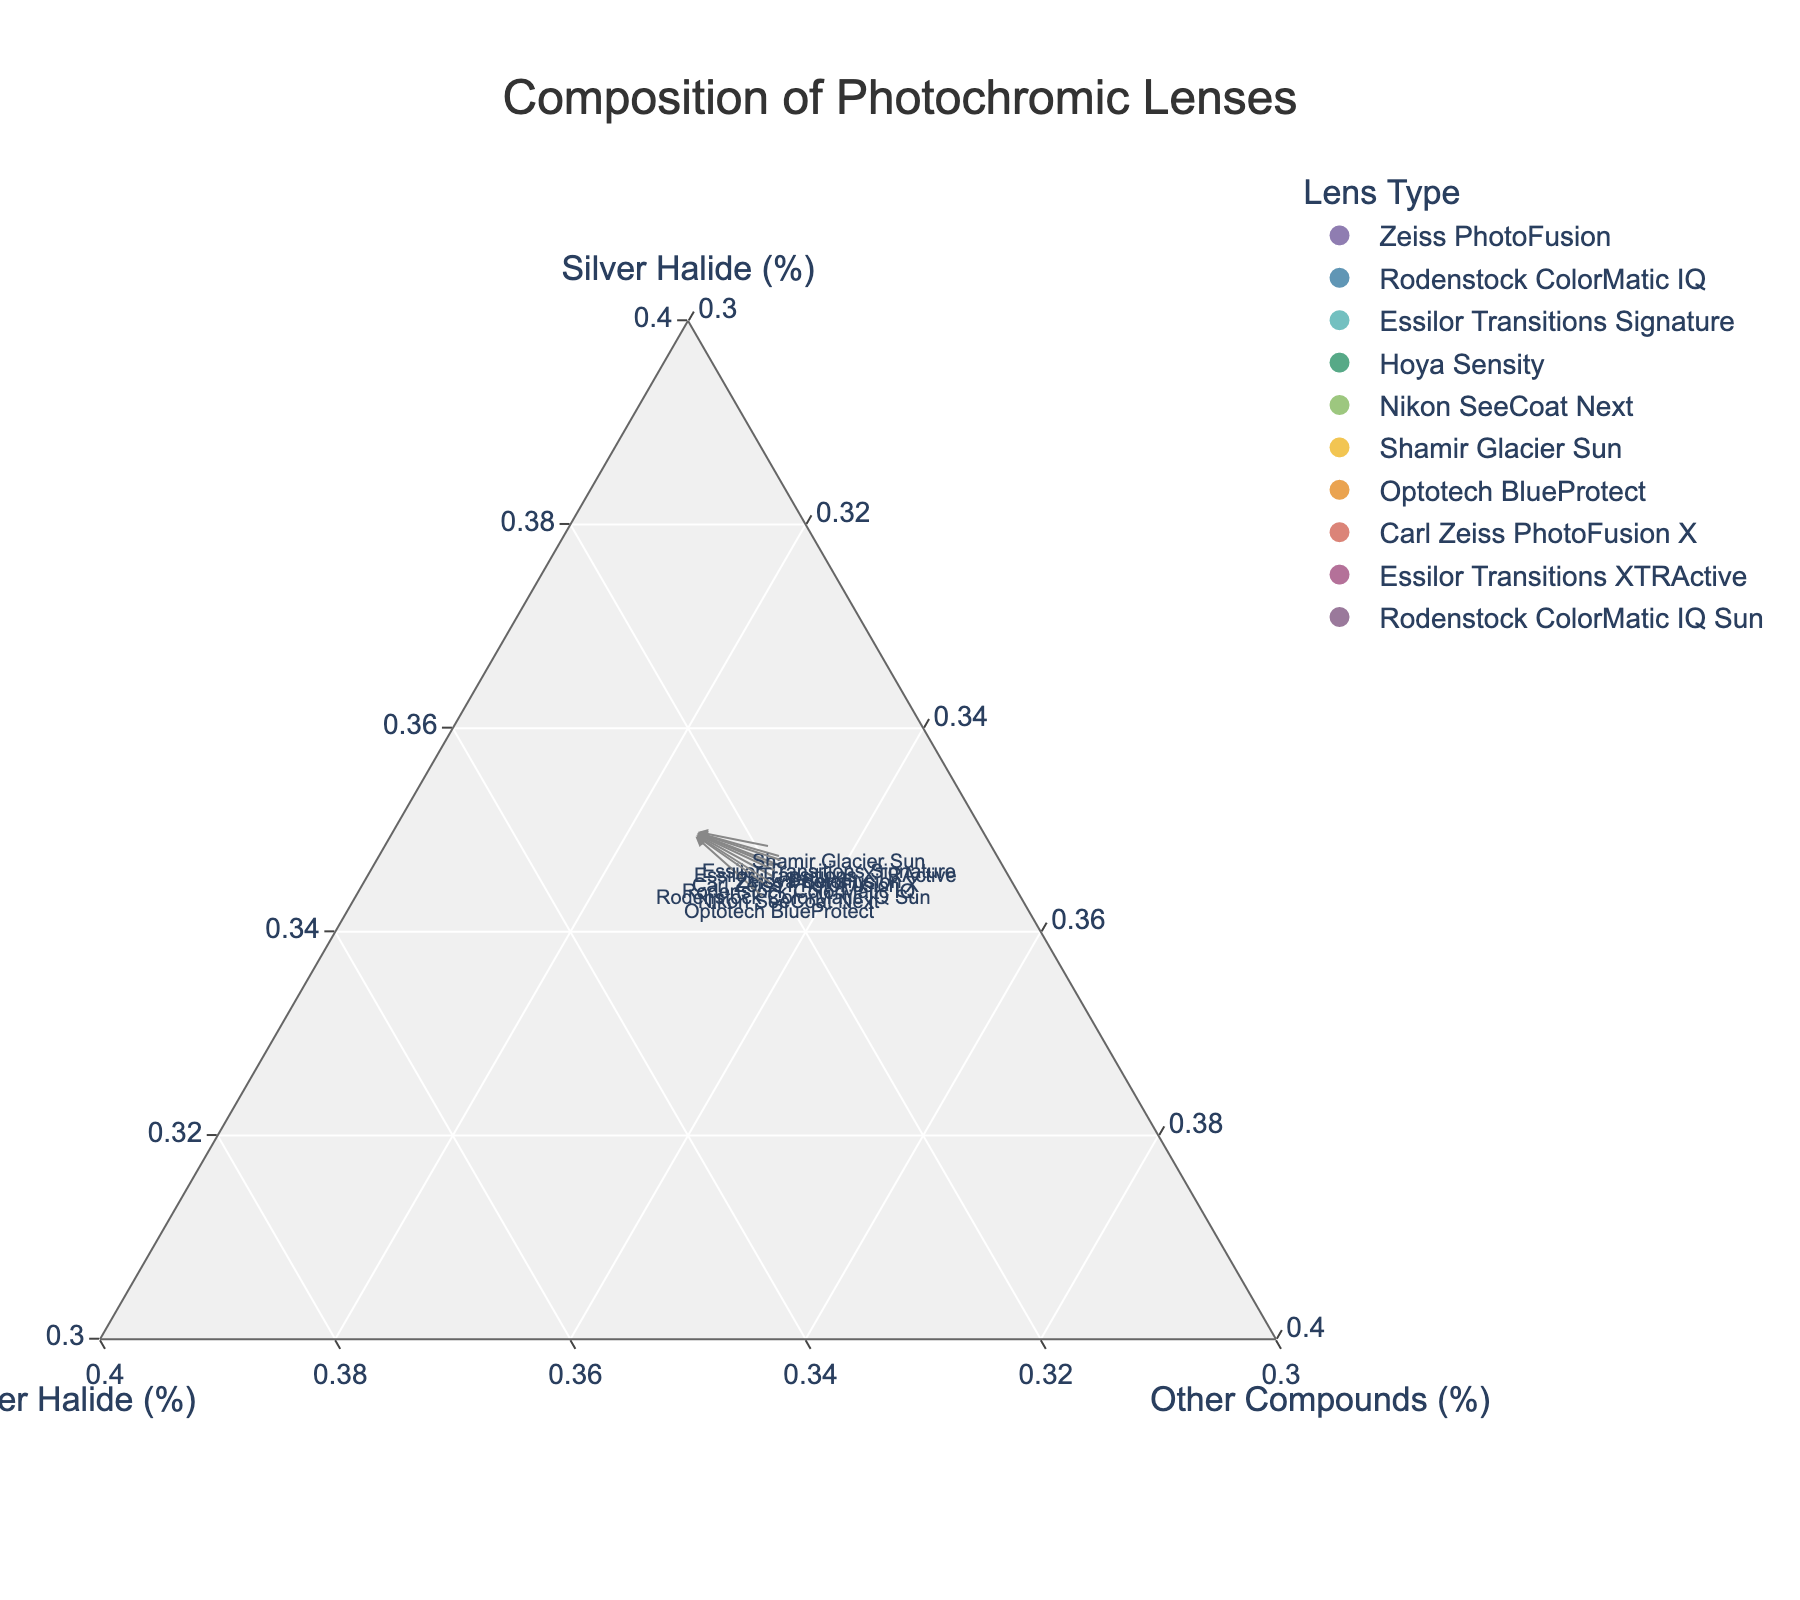What is the title of the figure? The title of the figure is prominently displayed at the top and is typically in a larger font size than the other text. It reads: "Composition of Photochromic Lenses."
Answer: Composition of Photochromic Lenses How many different lens types are displayed in the plot? The plot shows individual data points, each corresponding to a specific lens type. By counting the distinct color-coded points and ensuring none overlap, you can determine the total number of lens types.
Answer: 10 Which lens type has the highest percentage of Silver Halide? To find the lens type with the highest percentage of Silver Halide, locate the point closest to the "Silver Halide" corner of the ternary plot. This point represents the lens type with the highest Silver Halide percentage.
Answer: Shamir Glacier Sun What is the percentage composition of Copper Halide for the Optotech BlueProtect lens? Locate the corresponding point for Optotech BlueProtect and read the value along the Copper Halide axis.
Answer: 40% Which lens type has an equal percentage of Copper Halide and Other Compounds? Look for a lens type whose point lies on the line where the percentages of Copper Halide and Other Compounds are equal. By comparing the points, you find that some lenses have more balanced compositions.
Answer: None What is the average percentage of Copper Halide in all the lenses? To compute this, sum up the Copper Halide percentages of all lens types and divide by the total number of lens types. The sum is (25+30+20+25+35+15+40+27+22+33) = 272. Dividing by 10 lens types gives an average.
Answer: 27.2% Which two lens types have the largest difference in Copper Halide percentage? Compare the Copper Halide percentages for each lens type pairwise, identify the maximum and minimum values (40% for Optotech BlueProtect and 15% for Shamir Glacier Sun), then subtract the latter from the former.
Answer: Optotech BlueProtect and Shamir Glacier Sun Considering only Zeiss PhotoFusion and Carl Zeiss PhotoFusion X, which one has a higher percentage of Other Compounds? Compare the percentages for "Other Compounds" directly from the ternary plot data points. Zeiss PhotoFusion has 10%, whereas Carl Zeiss PhotoFusion X has 15%.
Answer: Carl Zeiss PhotoFusion X Which lens type stands closest to the center of the ternary plot? The center of the ternary plot represents equal parts of all three components. Find the point that appears closest to this central position by visual inspection.
Answer: Rodenstock ColorMatic IQ What is the average percentage of Silver Halide for lenses with more than 30% Copper Halide? Identify lens types with more than 30% Copper Halide: Nikon SeeCoat Next (35%) and Optotech BlueProtect (40%). The Silver Halide percentages for these are 50% and 45%, respectively. Sum these (50+45) = 95 and divide by 2 lens types.
Answer: 47.5% 